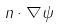Convert formula to latex. <formula><loc_0><loc_0><loc_500><loc_500>n \cdot \nabla \psi</formula> 